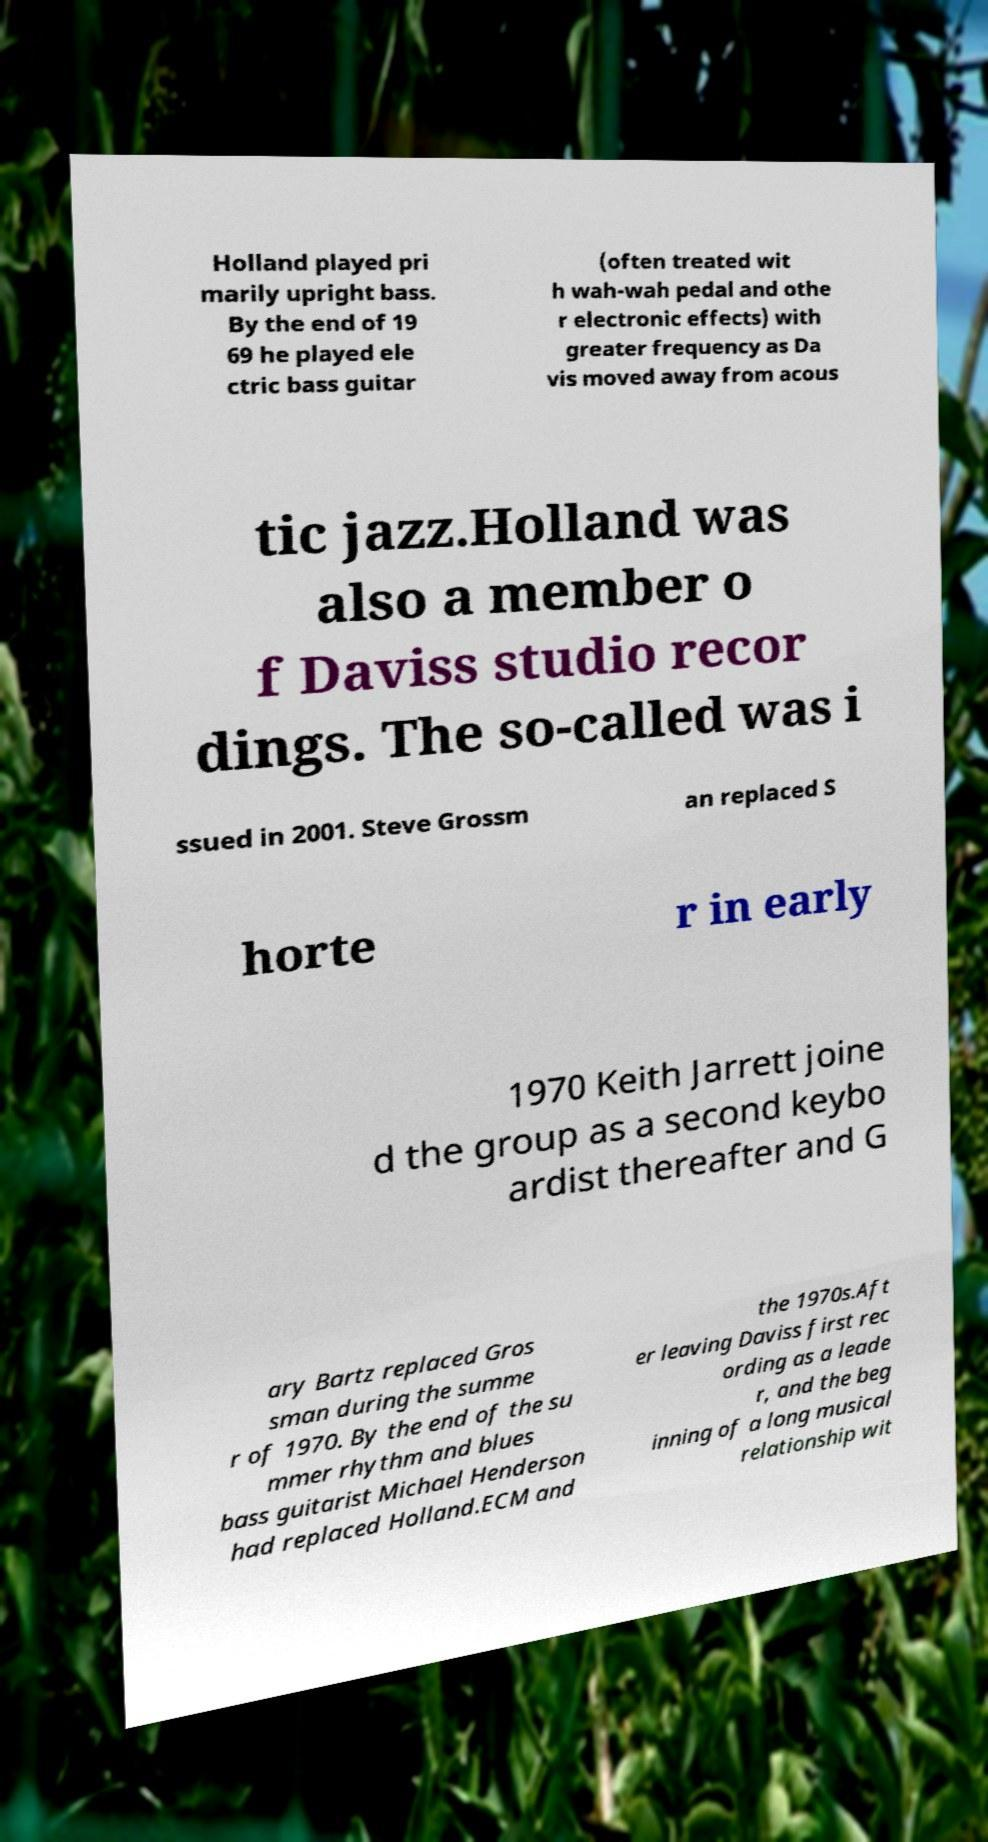Please read and relay the text visible in this image. What does it say? Holland played pri marily upright bass. By the end of 19 69 he played ele ctric bass guitar (often treated wit h wah-wah pedal and othe r electronic effects) with greater frequency as Da vis moved away from acous tic jazz.Holland was also a member o f Daviss studio recor dings. The so-called was i ssued in 2001. Steve Grossm an replaced S horte r in early 1970 Keith Jarrett joine d the group as a second keybo ardist thereafter and G ary Bartz replaced Gros sman during the summe r of 1970. By the end of the su mmer rhythm and blues bass guitarist Michael Henderson had replaced Holland.ECM and the 1970s.Aft er leaving Daviss first rec ording as a leade r, and the beg inning of a long musical relationship wit 